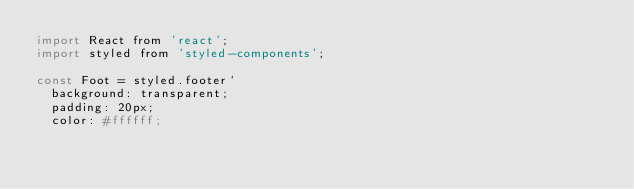<code> <loc_0><loc_0><loc_500><loc_500><_JavaScript_>import React from 'react';
import styled from 'styled-components';

const Foot = styled.footer`
  background: transparent;
  padding: 20px;
  color: #ffffff;</code> 